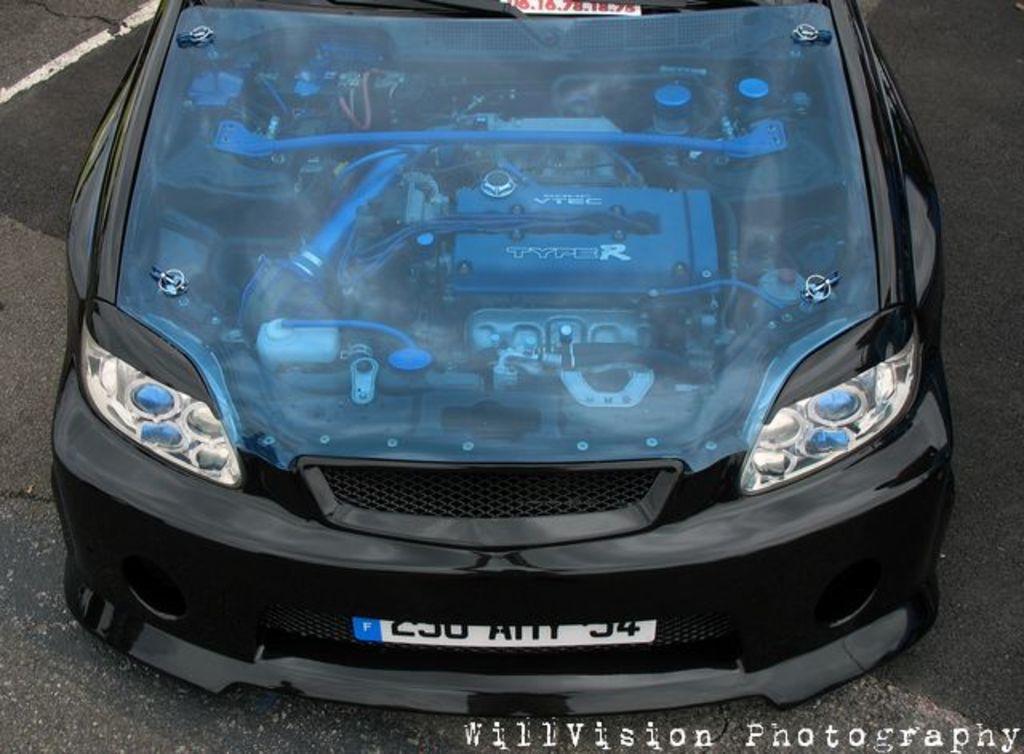Describe this image in one or two sentences. In this picture there is a black car. Here we can see engine. On the bottom right corner there is a watermark. On the right there is a road. 